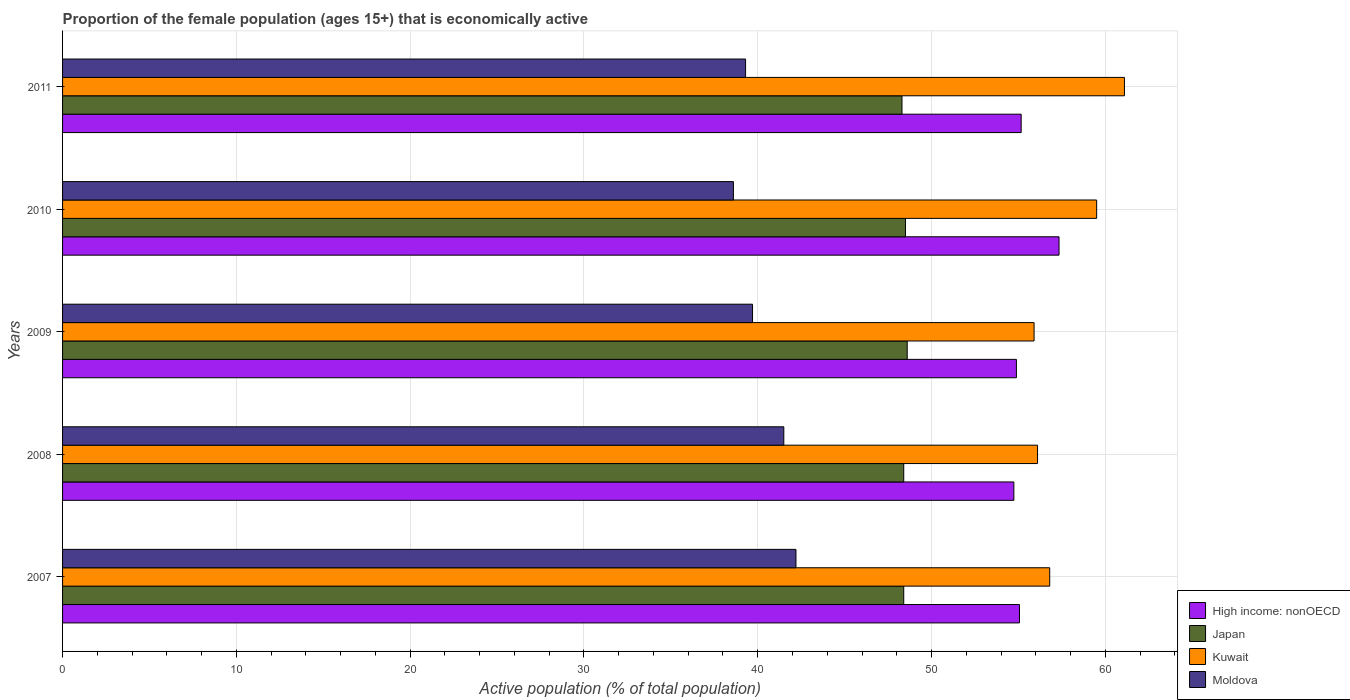Are the number of bars per tick equal to the number of legend labels?
Give a very brief answer. Yes. What is the label of the 1st group of bars from the top?
Your answer should be compact. 2011. What is the proportion of the female population that is economically active in Japan in 2011?
Provide a short and direct response. 48.3. Across all years, what is the maximum proportion of the female population that is economically active in Moldova?
Make the answer very short. 42.2. Across all years, what is the minimum proportion of the female population that is economically active in Kuwait?
Keep it short and to the point. 55.9. In which year was the proportion of the female population that is economically active in High income: nonOECD maximum?
Make the answer very short. 2010. In which year was the proportion of the female population that is economically active in Japan minimum?
Keep it short and to the point. 2011. What is the total proportion of the female population that is economically active in Moldova in the graph?
Your response must be concise. 201.3. What is the difference between the proportion of the female population that is economically active in Moldova in 2009 and that in 2010?
Your response must be concise. 1.1. What is the difference between the proportion of the female population that is economically active in Japan in 2008 and the proportion of the female population that is economically active in Moldova in 2007?
Your answer should be very brief. 6.2. What is the average proportion of the female population that is economically active in Moldova per year?
Keep it short and to the point. 40.26. In the year 2008, what is the difference between the proportion of the female population that is economically active in Kuwait and proportion of the female population that is economically active in High income: nonOECD?
Provide a short and direct response. 1.36. In how many years, is the proportion of the female population that is economically active in Japan greater than 62 %?
Your response must be concise. 0. What is the ratio of the proportion of the female population that is economically active in High income: nonOECD in 2008 to that in 2010?
Your answer should be compact. 0.95. Is the proportion of the female population that is economically active in Moldova in 2007 less than that in 2011?
Provide a short and direct response. No. Is the difference between the proportion of the female population that is economically active in Kuwait in 2007 and 2011 greater than the difference between the proportion of the female population that is economically active in High income: nonOECD in 2007 and 2011?
Keep it short and to the point. No. What is the difference between the highest and the second highest proportion of the female population that is economically active in High income: nonOECD?
Keep it short and to the point. 2.18. What is the difference between the highest and the lowest proportion of the female population that is economically active in Japan?
Your response must be concise. 0.3. What does the 2nd bar from the top in 2009 represents?
Make the answer very short. Kuwait. What does the 1st bar from the bottom in 2007 represents?
Keep it short and to the point. High income: nonOECD. Are all the bars in the graph horizontal?
Your response must be concise. Yes. How many years are there in the graph?
Your response must be concise. 5. What is the difference between two consecutive major ticks on the X-axis?
Make the answer very short. 10. How many legend labels are there?
Your response must be concise. 4. What is the title of the graph?
Your answer should be compact. Proportion of the female population (ages 15+) that is economically active. Does "Bahrain" appear as one of the legend labels in the graph?
Provide a short and direct response. No. What is the label or title of the X-axis?
Your answer should be very brief. Active population (% of total population). What is the label or title of the Y-axis?
Your answer should be compact. Years. What is the Active population (% of total population) in High income: nonOECD in 2007?
Provide a short and direct response. 55.06. What is the Active population (% of total population) in Japan in 2007?
Offer a terse response. 48.4. What is the Active population (% of total population) of Kuwait in 2007?
Your answer should be compact. 56.8. What is the Active population (% of total population) in Moldova in 2007?
Give a very brief answer. 42.2. What is the Active population (% of total population) of High income: nonOECD in 2008?
Your answer should be compact. 54.74. What is the Active population (% of total population) of Japan in 2008?
Your response must be concise. 48.4. What is the Active population (% of total population) of Kuwait in 2008?
Your answer should be compact. 56.1. What is the Active population (% of total population) of Moldova in 2008?
Give a very brief answer. 41.5. What is the Active population (% of total population) of High income: nonOECD in 2009?
Provide a short and direct response. 54.88. What is the Active population (% of total population) of Japan in 2009?
Give a very brief answer. 48.6. What is the Active population (% of total population) of Kuwait in 2009?
Give a very brief answer. 55.9. What is the Active population (% of total population) of Moldova in 2009?
Keep it short and to the point. 39.7. What is the Active population (% of total population) of High income: nonOECD in 2010?
Provide a short and direct response. 57.34. What is the Active population (% of total population) of Japan in 2010?
Provide a succinct answer. 48.5. What is the Active population (% of total population) in Kuwait in 2010?
Your response must be concise. 59.5. What is the Active population (% of total population) in Moldova in 2010?
Offer a very short reply. 38.6. What is the Active population (% of total population) in High income: nonOECD in 2011?
Provide a succinct answer. 55.16. What is the Active population (% of total population) of Japan in 2011?
Ensure brevity in your answer.  48.3. What is the Active population (% of total population) in Kuwait in 2011?
Provide a short and direct response. 61.1. What is the Active population (% of total population) in Moldova in 2011?
Your answer should be very brief. 39.3. Across all years, what is the maximum Active population (% of total population) in High income: nonOECD?
Offer a very short reply. 57.34. Across all years, what is the maximum Active population (% of total population) of Japan?
Your answer should be compact. 48.6. Across all years, what is the maximum Active population (% of total population) in Kuwait?
Offer a very short reply. 61.1. Across all years, what is the maximum Active population (% of total population) in Moldova?
Make the answer very short. 42.2. Across all years, what is the minimum Active population (% of total population) in High income: nonOECD?
Give a very brief answer. 54.74. Across all years, what is the minimum Active population (% of total population) of Japan?
Provide a short and direct response. 48.3. Across all years, what is the minimum Active population (% of total population) in Kuwait?
Your answer should be compact. 55.9. Across all years, what is the minimum Active population (% of total population) of Moldova?
Make the answer very short. 38.6. What is the total Active population (% of total population) in High income: nonOECD in the graph?
Your response must be concise. 277.17. What is the total Active population (% of total population) of Japan in the graph?
Ensure brevity in your answer.  242.2. What is the total Active population (% of total population) in Kuwait in the graph?
Keep it short and to the point. 289.4. What is the total Active population (% of total population) in Moldova in the graph?
Provide a succinct answer. 201.3. What is the difference between the Active population (% of total population) in High income: nonOECD in 2007 and that in 2008?
Your answer should be very brief. 0.32. What is the difference between the Active population (% of total population) of Moldova in 2007 and that in 2008?
Provide a short and direct response. 0.7. What is the difference between the Active population (% of total population) in High income: nonOECD in 2007 and that in 2009?
Your response must be concise. 0.18. What is the difference between the Active population (% of total population) of Japan in 2007 and that in 2009?
Ensure brevity in your answer.  -0.2. What is the difference between the Active population (% of total population) of High income: nonOECD in 2007 and that in 2010?
Offer a very short reply. -2.28. What is the difference between the Active population (% of total population) of Kuwait in 2007 and that in 2010?
Offer a terse response. -2.7. What is the difference between the Active population (% of total population) of High income: nonOECD in 2007 and that in 2011?
Provide a succinct answer. -0.1. What is the difference between the Active population (% of total population) of Moldova in 2007 and that in 2011?
Provide a succinct answer. 2.9. What is the difference between the Active population (% of total population) in High income: nonOECD in 2008 and that in 2009?
Provide a succinct answer. -0.15. What is the difference between the Active population (% of total population) in Kuwait in 2008 and that in 2009?
Offer a terse response. 0.2. What is the difference between the Active population (% of total population) in High income: nonOECD in 2008 and that in 2010?
Give a very brief answer. -2.6. What is the difference between the Active population (% of total population) of Japan in 2008 and that in 2010?
Provide a short and direct response. -0.1. What is the difference between the Active population (% of total population) of High income: nonOECD in 2008 and that in 2011?
Give a very brief answer. -0.42. What is the difference between the Active population (% of total population) of Japan in 2008 and that in 2011?
Provide a succinct answer. 0.1. What is the difference between the Active population (% of total population) in Kuwait in 2008 and that in 2011?
Provide a short and direct response. -5. What is the difference between the Active population (% of total population) in High income: nonOECD in 2009 and that in 2010?
Provide a short and direct response. -2.45. What is the difference between the Active population (% of total population) of Kuwait in 2009 and that in 2010?
Your response must be concise. -3.6. What is the difference between the Active population (% of total population) of Moldova in 2009 and that in 2010?
Offer a terse response. 1.1. What is the difference between the Active population (% of total population) of High income: nonOECD in 2009 and that in 2011?
Provide a short and direct response. -0.27. What is the difference between the Active population (% of total population) of Moldova in 2009 and that in 2011?
Your response must be concise. 0.4. What is the difference between the Active population (% of total population) in High income: nonOECD in 2010 and that in 2011?
Offer a terse response. 2.18. What is the difference between the Active population (% of total population) in Japan in 2010 and that in 2011?
Provide a short and direct response. 0.2. What is the difference between the Active population (% of total population) of High income: nonOECD in 2007 and the Active population (% of total population) of Japan in 2008?
Provide a succinct answer. 6.66. What is the difference between the Active population (% of total population) in High income: nonOECD in 2007 and the Active population (% of total population) in Kuwait in 2008?
Ensure brevity in your answer.  -1.04. What is the difference between the Active population (% of total population) in High income: nonOECD in 2007 and the Active population (% of total population) in Moldova in 2008?
Your answer should be compact. 13.56. What is the difference between the Active population (% of total population) in Kuwait in 2007 and the Active population (% of total population) in Moldova in 2008?
Offer a terse response. 15.3. What is the difference between the Active population (% of total population) of High income: nonOECD in 2007 and the Active population (% of total population) of Japan in 2009?
Offer a very short reply. 6.46. What is the difference between the Active population (% of total population) of High income: nonOECD in 2007 and the Active population (% of total population) of Kuwait in 2009?
Make the answer very short. -0.84. What is the difference between the Active population (% of total population) of High income: nonOECD in 2007 and the Active population (% of total population) of Moldova in 2009?
Provide a succinct answer. 15.36. What is the difference between the Active population (% of total population) in Japan in 2007 and the Active population (% of total population) in Kuwait in 2009?
Your answer should be compact. -7.5. What is the difference between the Active population (% of total population) in Kuwait in 2007 and the Active population (% of total population) in Moldova in 2009?
Keep it short and to the point. 17.1. What is the difference between the Active population (% of total population) of High income: nonOECD in 2007 and the Active population (% of total population) of Japan in 2010?
Your answer should be compact. 6.56. What is the difference between the Active population (% of total population) in High income: nonOECD in 2007 and the Active population (% of total population) in Kuwait in 2010?
Ensure brevity in your answer.  -4.44. What is the difference between the Active population (% of total population) of High income: nonOECD in 2007 and the Active population (% of total population) of Moldova in 2010?
Give a very brief answer. 16.46. What is the difference between the Active population (% of total population) of Japan in 2007 and the Active population (% of total population) of Moldova in 2010?
Give a very brief answer. 9.8. What is the difference between the Active population (% of total population) in Kuwait in 2007 and the Active population (% of total population) in Moldova in 2010?
Make the answer very short. 18.2. What is the difference between the Active population (% of total population) in High income: nonOECD in 2007 and the Active population (% of total population) in Japan in 2011?
Provide a succinct answer. 6.76. What is the difference between the Active population (% of total population) in High income: nonOECD in 2007 and the Active population (% of total population) in Kuwait in 2011?
Give a very brief answer. -6.04. What is the difference between the Active population (% of total population) of High income: nonOECD in 2007 and the Active population (% of total population) of Moldova in 2011?
Keep it short and to the point. 15.76. What is the difference between the Active population (% of total population) in Japan in 2007 and the Active population (% of total population) in Kuwait in 2011?
Offer a terse response. -12.7. What is the difference between the Active population (% of total population) of Japan in 2007 and the Active population (% of total population) of Moldova in 2011?
Your answer should be compact. 9.1. What is the difference between the Active population (% of total population) of High income: nonOECD in 2008 and the Active population (% of total population) of Japan in 2009?
Make the answer very short. 6.14. What is the difference between the Active population (% of total population) of High income: nonOECD in 2008 and the Active population (% of total population) of Kuwait in 2009?
Give a very brief answer. -1.16. What is the difference between the Active population (% of total population) in High income: nonOECD in 2008 and the Active population (% of total population) in Moldova in 2009?
Offer a terse response. 15.04. What is the difference between the Active population (% of total population) in Japan in 2008 and the Active population (% of total population) in Kuwait in 2009?
Offer a very short reply. -7.5. What is the difference between the Active population (% of total population) in Japan in 2008 and the Active population (% of total population) in Moldova in 2009?
Keep it short and to the point. 8.7. What is the difference between the Active population (% of total population) of Kuwait in 2008 and the Active population (% of total population) of Moldova in 2009?
Provide a short and direct response. 16.4. What is the difference between the Active population (% of total population) of High income: nonOECD in 2008 and the Active population (% of total population) of Japan in 2010?
Offer a very short reply. 6.24. What is the difference between the Active population (% of total population) of High income: nonOECD in 2008 and the Active population (% of total population) of Kuwait in 2010?
Your answer should be compact. -4.76. What is the difference between the Active population (% of total population) in High income: nonOECD in 2008 and the Active population (% of total population) in Moldova in 2010?
Ensure brevity in your answer.  16.14. What is the difference between the Active population (% of total population) of Japan in 2008 and the Active population (% of total population) of Moldova in 2010?
Your answer should be compact. 9.8. What is the difference between the Active population (% of total population) in High income: nonOECD in 2008 and the Active population (% of total population) in Japan in 2011?
Provide a short and direct response. 6.44. What is the difference between the Active population (% of total population) in High income: nonOECD in 2008 and the Active population (% of total population) in Kuwait in 2011?
Make the answer very short. -6.36. What is the difference between the Active population (% of total population) of High income: nonOECD in 2008 and the Active population (% of total population) of Moldova in 2011?
Make the answer very short. 15.44. What is the difference between the Active population (% of total population) in Japan in 2008 and the Active population (% of total population) in Kuwait in 2011?
Offer a very short reply. -12.7. What is the difference between the Active population (% of total population) in High income: nonOECD in 2009 and the Active population (% of total population) in Japan in 2010?
Give a very brief answer. 6.38. What is the difference between the Active population (% of total population) of High income: nonOECD in 2009 and the Active population (% of total population) of Kuwait in 2010?
Your answer should be very brief. -4.62. What is the difference between the Active population (% of total population) of High income: nonOECD in 2009 and the Active population (% of total population) of Moldova in 2010?
Keep it short and to the point. 16.28. What is the difference between the Active population (% of total population) of High income: nonOECD in 2009 and the Active population (% of total population) of Japan in 2011?
Ensure brevity in your answer.  6.58. What is the difference between the Active population (% of total population) in High income: nonOECD in 2009 and the Active population (% of total population) in Kuwait in 2011?
Make the answer very short. -6.22. What is the difference between the Active population (% of total population) in High income: nonOECD in 2009 and the Active population (% of total population) in Moldova in 2011?
Give a very brief answer. 15.58. What is the difference between the Active population (% of total population) of Japan in 2009 and the Active population (% of total population) of Moldova in 2011?
Offer a terse response. 9.3. What is the difference between the Active population (% of total population) in Kuwait in 2009 and the Active population (% of total population) in Moldova in 2011?
Make the answer very short. 16.6. What is the difference between the Active population (% of total population) in High income: nonOECD in 2010 and the Active population (% of total population) in Japan in 2011?
Make the answer very short. 9.04. What is the difference between the Active population (% of total population) of High income: nonOECD in 2010 and the Active population (% of total population) of Kuwait in 2011?
Ensure brevity in your answer.  -3.76. What is the difference between the Active population (% of total population) in High income: nonOECD in 2010 and the Active population (% of total population) in Moldova in 2011?
Ensure brevity in your answer.  18.04. What is the difference between the Active population (% of total population) in Kuwait in 2010 and the Active population (% of total population) in Moldova in 2011?
Your response must be concise. 20.2. What is the average Active population (% of total population) in High income: nonOECD per year?
Keep it short and to the point. 55.43. What is the average Active population (% of total population) of Japan per year?
Your answer should be compact. 48.44. What is the average Active population (% of total population) in Kuwait per year?
Ensure brevity in your answer.  57.88. What is the average Active population (% of total population) in Moldova per year?
Your answer should be compact. 40.26. In the year 2007, what is the difference between the Active population (% of total population) of High income: nonOECD and Active population (% of total population) of Japan?
Provide a short and direct response. 6.66. In the year 2007, what is the difference between the Active population (% of total population) in High income: nonOECD and Active population (% of total population) in Kuwait?
Make the answer very short. -1.74. In the year 2007, what is the difference between the Active population (% of total population) in High income: nonOECD and Active population (% of total population) in Moldova?
Give a very brief answer. 12.86. In the year 2007, what is the difference between the Active population (% of total population) of Japan and Active population (% of total population) of Kuwait?
Provide a succinct answer. -8.4. In the year 2008, what is the difference between the Active population (% of total population) of High income: nonOECD and Active population (% of total population) of Japan?
Provide a succinct answer. 6.34. In the year 2008, what is the difference between the Active population (% of total population) of High income: nonOECD and Active population (% of total population) of Kuwait?
Your answer should be compact. -1.36. In the year 2008, what is the difference between the Active population (% of total population) in High income: nonOECD and Active population (% of total population) in Moldova?
Your response must be concise. 13.24. In the year 2008, what is the difference between the Active population (% of total population) in Japan and Active population (% of total population) in Kuwait?
Offer a terse response. -7.7. In the year 2008, what is the difference between the Active population (% of total population) in Kuwait and Active population (% of total population) in Moldova?
Keep it short and to the point. 14.6. In the year 2009, what is the difference between the Active population (% of total population) of High income: nonOECD and Active population (% of total population) of Japan?
Your answer should be compact. 6.28. In the year 2009, what is the difference between the Active population (% of total population) of High income: nonOECD and Active population (% of total population) of Kuwait?
Offer a terse response. -1.02. In the year 2009, what is the difference between the Active population (% of total population) in High income: nonOECD and Active population (% of total population) in Moldova?
Offer a very short reply. 15.18. In the year 2009, what is the difference between the Active population (% of total population) of Japan and Active population (% of total population) of Moldova?
Keep it short and to the point. 8.9. In the year 2010, what is the difference between the Active population (% of total population) of High income: nonOECD and Active population (% of total population) of Japan?
Your response must be concise. 8.84. In the year 2010, what is the difference between the Active population (% of total population) in High income: nonOECD and Active population (% of total population) in Kuwait?
Give a very brief answer. -2.16. In the year 2010, what is the difference between the Active population (% of total population) in High income: nonOECD and Active population (% of total population) in Moldova?
Ensure brevity in your answer.  18.74. In the year 2010, what is the difference between the Active population (% of total population) in Japan and Active population (% of total population) in Kuwait?
Make the answer very short. -11. In the year 2010, what is the difference between the Active population (% of total population) in Kuwait and Active population (% of total population) in Moldova?
Ensure brevity in your answer.  20.9. In the year 2011, what is the difference between the Active population (% of total population) of High income: nonOECD and Active population (% of total population) of Japan?
Offer a very short reply. 6.86. In the year 2011, what is the difference between the Active population (% of total population) of High income: nonOECD and Active population (% of total population) of Kuwait?
Give a very brief answer. -5.94. In the year 2011, what is the difference between the Active population (% of total population) of High income: nonOECD and Active population (% of total population) of Moldova?
Keep it short and to the point. 15.86. In the year 2011, what is the difference between the Active population (% of total population) in Kuwait and Active population (% of total population) in Moldova?
Ensure brevity in your answer.  21.8. What is the ratio of the Active population (% of total population) in High income: nonOECD in 2007 to that in 2008?
Provide a succinct answer. 1.01. What is the ratio of the Active population (% of total population) in Kuwait in 2007 to that in 2008?
Keep it short and to the point. 1.01. What is the ratio of the Active population (% of total population) of Moldova in 2007 to that in 2008?
Provide a succinct answer. 1.02. What is the ratio of the Active population (% of total population) of High income: nonOECD in 2007 to that in 2009?
Your response must be concise. 1. What is the ratio of the Active population (% of total population) in Kuwait in 2007 to that in 2009?
Your response must be concise. 1.02. What is the ratio of the Active population (% of total population) in Moldova in 2007 to that in 2009?
Offer a terse response. 1.06. What is the ratio of the Active population (% of total population) in High income: nonOECD in 2007 to that in 2010?
Give a very brief answer. 0.96. What is the ratio of the Active population (% of total population) of Kuwait in 2007 to that in 2010?
Keep it short and to the point. 0.95. What is the ratio of the Active population (% of total population) in Moldova in 2007 to that in 2010?
Your answer should be very brief. 1.09. What is the ratio of the Active population (% of total population) of Kuwait in 2007 to that in 2011?
Provide a succinct answer. 0.93. What is the ratio of the Active population (% of total population) of Moldova in 2007 to that in 2011?
Keep it short and to the point. 1.07. What is the ratio of the Active population (% of total population) in High income: nonOECD in 2008 to that in 2009?
Keep it short and to the point. 1. What is the ratio of the Active population (% of total population) in Moldova in 2008 to that in 2009?
Give a very brief answer. 1.05. What is the ratio of the Active population (% of total population) in High income: nonOECD in 2008 to that in 2010?
Your answer should be compact. 0.95. What is the ratio of the Active population (% of total population) in Kuwait in 2008 to that in 2010?
Offer a very short reply. 0.94. What is the ratio of the Active population (% of total population) of Moldova in 2008 to that in 2010?
Keep it short and to the point. 1.08. What is the ratio of the Active population (% of total population) of High income: nonOECD in 2008 to that in 2011?
Make the answer very short. 0.99. What is the ratio of the Active population (% of total population) in Japan in 2008 to that in 2011?
Provide a succinct answer. 1. What is the ratio of the Active population (% of total population) in Kuwait in 2008 to that in 2011?
Give a very brief answer. 0.92. What is the ratio of the Active population (% of total population) in Moldova in 2008 to that in 2011?
Your response must be concise. 1.06. What is the ratio of the Active population (% of total population) in High income: nonOECD in 2009 to that in 2010?
Offer a terse response. 0.96. What is the ratio of the Active population (% of total population) in Japan in 2009 to that in 2010?
Your response must be concise. 1. What is the ratio of the Active population (% of total population) of Kuwait in 2009 to that in 2010?
Provide a short and direct response. 0.94. What is the ratio of the Active population (% of total population) of Moldova in 2009 to that in 2010?
Make the answer very short. 1.03. What is the ratio of the Active population (% of total population) of High income: nonOECD in 2009 to that in 2011?
Offer a terse response. 0.99. What is the ratio of the Active population (% of total population) of Japan in 2009 to that in 2011?
Offer a very short reply. 1.01. What is the ratio of the Active population (% of total population) of Kuwait in 2009 to that in 2011?
Give a very brief answer. 0.91. What is the ratio of the Active population (% of total population) in Moldova in 2009 to that in 2011?
Provide a succinct answer. 1.01. What is the ratio of the Active population (% of total population) in High income: nonOECD in 2010 to that in 2011?
Make the answer very short. 1.04. What is the ratio of the Active population (% of total population) of Kuwait in 2010 to that in 2011?
Offer a very short reply. 0.97. What is the ratio of the Active population (% of total population) in Moldova in 2010 to that in 2011?
Offer a terse response. 0.98. What is the difference between the highest and the second highest Active population (% of total population) of High income: nonOECD?
Offer a very short reply. 2.18. What is the difference between the highest and the lowest Active population (% of total population) in High income: nonOECD?
Your answer should be compact. 2.6. What is the difference between the highest and the lowest Active population (% of total population) in Kuwait?
Provide a succinct answer. 5.2. What is the difference between the highest and the lowest Active population (% of total population) of Moldova?
Offer a very short reply. 3.6. 